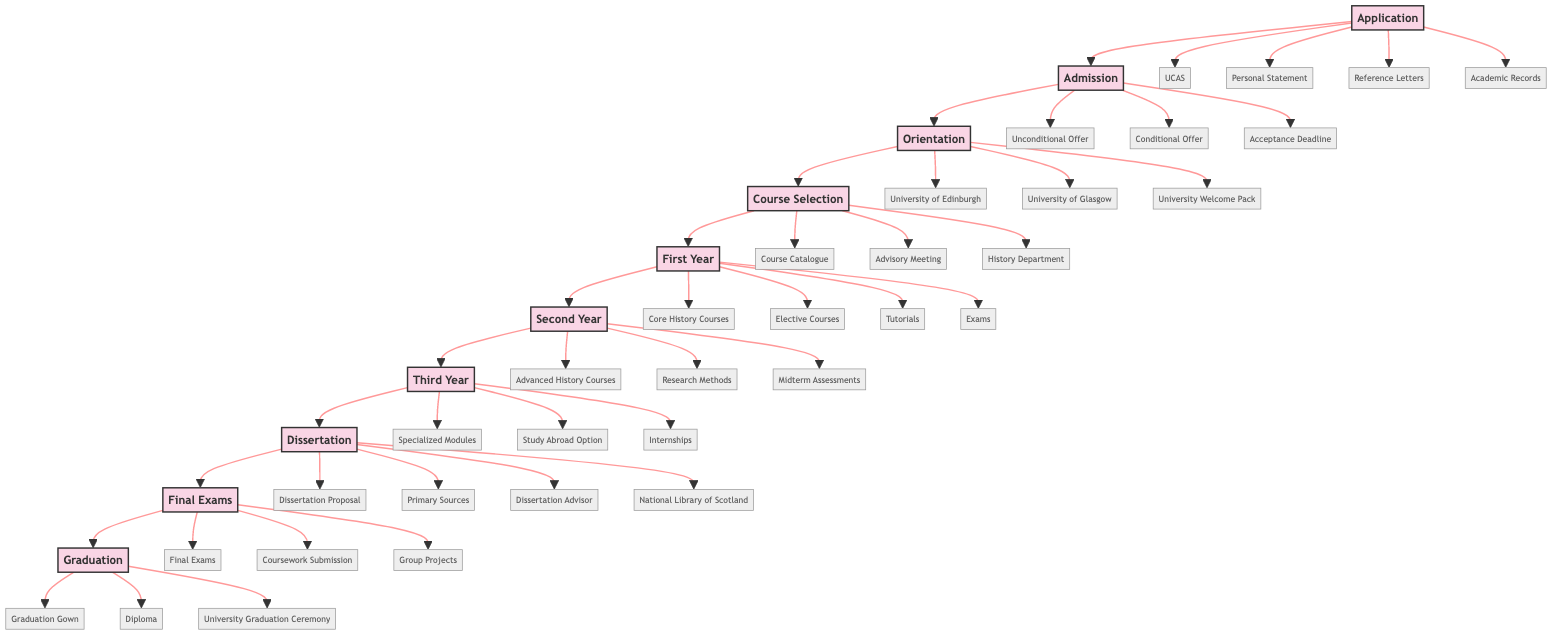What is the first step in the enrollment journey? The diagram shows "Application" as the first step from which the journey begins towards graduation.
Answer: Application How many courses must be selected in the Course Selection step? The Course Selection step requires choosing "initial courses", although the exact number is not specified, it indicates that at least multiple courses are involved.
Answer: Initial courses What two types of offers can be received during Admission? The Admission step indicates two types of offers: "Unconditional Offer" and "Conditional Offer".
Answer: Unconditional Offer, Conditional Offer What step follows after First Year? The sequence in the diagram shows that "Second Year" follows directly after "First Year".
Answer: Second Year What major assignment is completed in the Dissertation step? In the Dissertation step, students must complete a "dissertation", which is the main task.
Answer: Dissertation In which year can specialized history modules be engaged with? According to the flow chart, specialized history modules are engaged during "Third Year".
Answer: Third Year What is a key component of the Final Exams step? The diagram specifies that "Final Exams" is a key component of the Final Exams step, along with "Coursework Submission" and "Group Projects".
Answer: Final Exams What two entities are included in the Orientation step? The Orientation step includes "University of Edinburgh" and "University of Glasgow" as key entities during it.
Answer: University of Edinburgh, University of Glasgow What is the final step in the journey to graduation? The final step in the journey, as shown in the flow chart, is "Graduation".
Answer: Graduation 